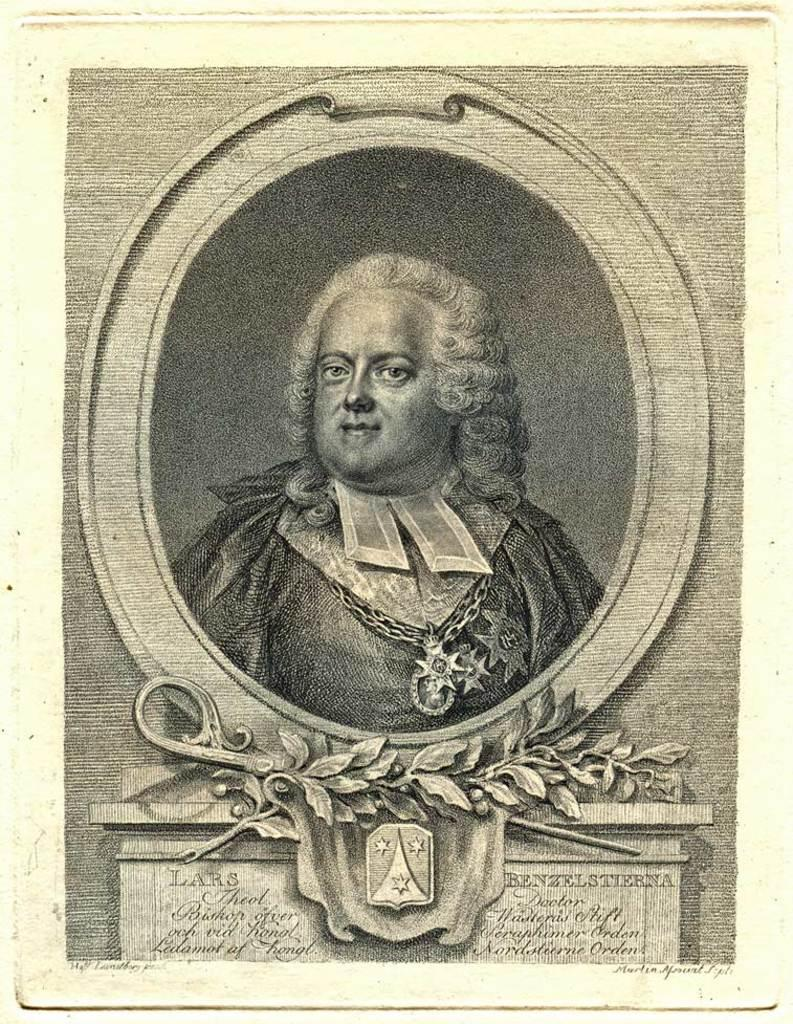What is the main subject of the image? There is a depiction of a person in the image. Is there any text present in the image? Yes, there is text at the bottom of the image. Can you see any ghosts interacting with the person in the image? There are no ghosts present in the image. Are there any horses visible in the image? There are no horses present in the image. 